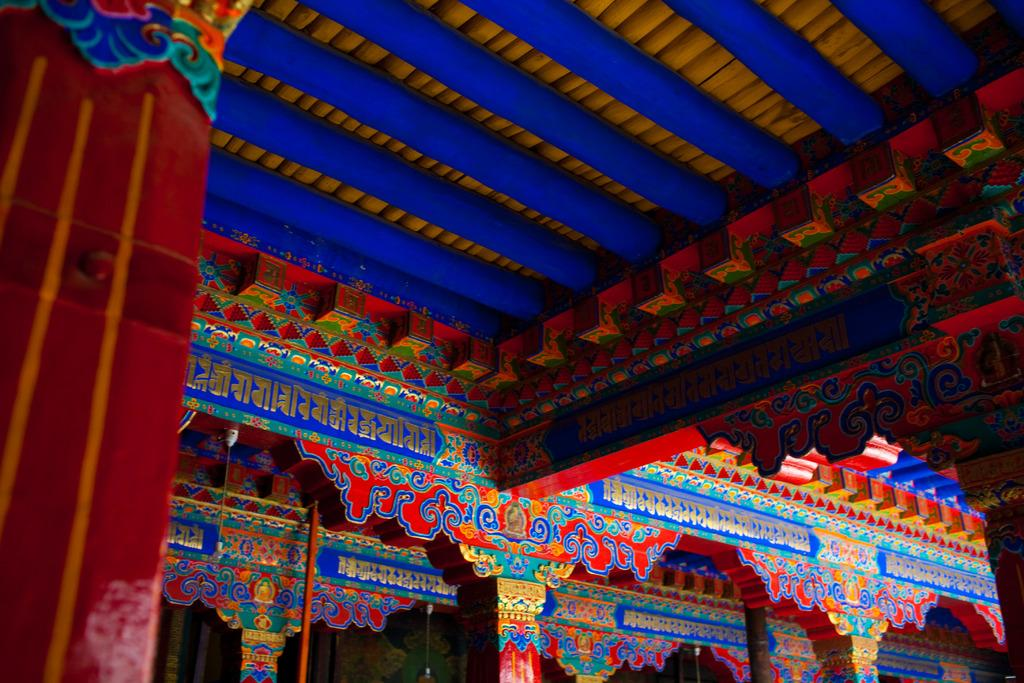What is present above the area shown in the image? There is a ceiling in the image. Can you describe the appearance of the ceiling? The ceiling has colorful designs. What color are the pillars in the image? The pillars in the image are red in color. What type of smell can be detected in the image? There is no information about smells in the image, so it cannot be determined from the image. 